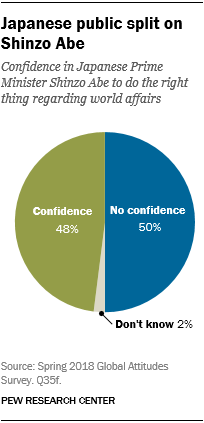Highlight a few significant elements in this photo. The terms 'no confidence' and 'confidence' have distinct meanings and connotations. While confidence generally implies trust and belief in oneself or in a particular entity, no confidence signifies a lack of confidence or belief in the ability or integrity of someone or something. There are three colors in the pie graph. 